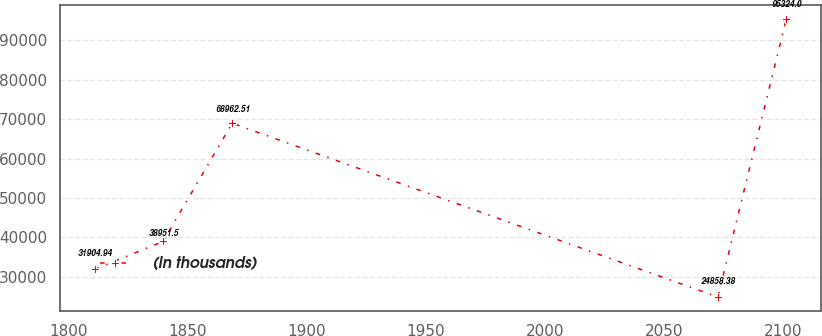<chart> <loc_0><loc_0><loc_500><loc_500><line_chart><ecel><fcel>(In thousands)<nl><fcel>1810.84<fcel>31904.9<nl><fcel>1839.56<fcel>38951.5<nl><fcel>1868.61<fcel>68962.5<nl><fcel>2072.71<fcel>24858.4<nl><fcel>2101.43<fcel>95324<nl></chart> 